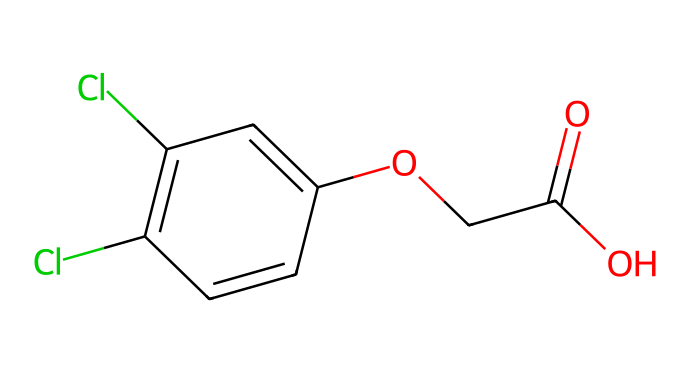What is the molecular formula of 2,4-D? By analyzing the SMILES representation, we can count the atoms indicated. The chemical has two chlorine (Cl), 10 carbon (C), 11 hydrogen (H), and 4 oxygen (O) atoms, leading to the molecular formula C8H6Cl2O3.
Answer: C8H6Cl2O3 How many rings are present in the structure of 2,4-D? The structure contains one six-membered aromatic ring based on the presence of alternating double bonds, which indicates cyclic behavior. There are no additional rings visible in the SMILES representation.
Answer: 1 What functional groups are present in 2,4-D? Analyzing the chemical structure shows that there is a phenol group (due to the -OH), an ester group (since the molecule has an alkyl ester's carbonyl attached to the -OCC), and a carboxylic acid group (-COOH). Therefore, the presence of these functional groups indicates the reactivity and properties of the herbicide.
Answer: Phenol, ester, carboxylic acid Which atom types contribute to the herbicidal activity of 2,4-D? In herbicides like 2,4-D, the presence of chlorine atoms is significant as they often enhance the substance's bioactivity and selectivity by disrupting plant growth. Coupled with the functionalities present, these atoms play a role in the herbicidal properties.
Answer: Chlorine What is the total number of oxygen atoms in 2,4-D? From the SMILES code, we can see clearly that there are a total of four oxygen (O) atoms included in the chemical structure, which correspond to the functional groups identified in the previous question.
Answer: 4 What effect do chlorine atoms have on the herbicidal properties of 2,4-D? Chlorine atoms increase the lipophilicity of the compound, which can enhance its ability to penetrate plant tissues. Additionally, they play a role in the selective herbicidal action by affecting the growth regulation pathways in plants.
Answer: Increased activity 